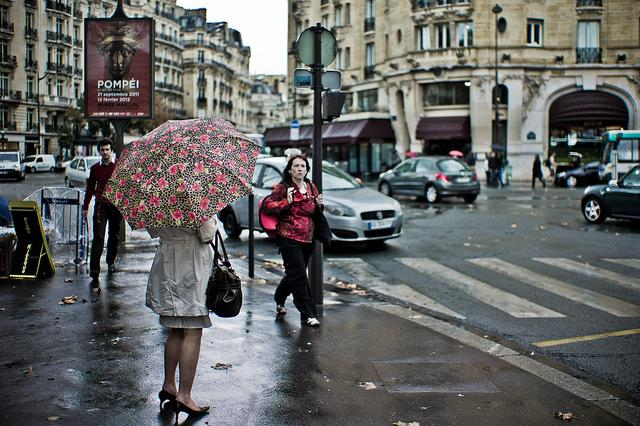When does the Pompeii exhibit end?

Choices:
A) 2010
B) 2011
C) 2012
D) 2013 2012 